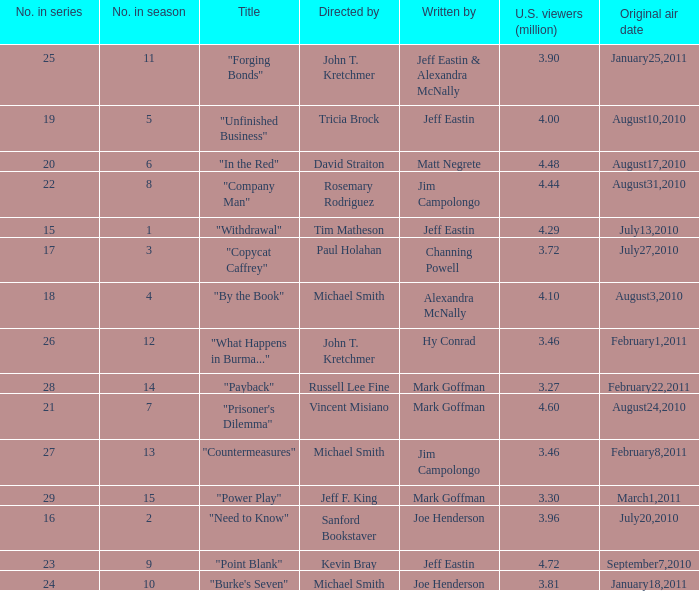How many millions of people in the US watched when Kevin Bray was director? 4.72. Write the full table. {'header': ['No. in series', 'No. in season', 'Title', 'Directed by', 'Written by', 'U.S. viewers (million)', 'Original air date'], 'rows': [['25', '11', '"Forging Bonds"', 'John T. Kretchmer', 'Jeff Eastin & Alexandra McNally', '3.90', 'January25,2011'], ['19', '5', '"Unfinished Business"', 'Tricia Brock', 'Jeff Eastin', '4.00', 'August10,2010'], ['20', '6', '"In the Red"', 'David Straiton', 'Matt Negrete', '4.48', 'August17,2010'], ['22', '8', '"Company Man"', 'Rosemary Rodriguez', 'Jim Campolongo', '4.44', 'August31,2010'], ['15', '1', '"Withdrawal"', 'Tim Matheson', 'Jeff Eastin', '4.29', 'July13,2010'], ['17', '3', '"Copycat Caffrey"', 'Paul Holahan', 'Channing Powell', '3.72', 'July27,2010'], ['18', '4', '"By the Book"', 'Michael Smith', 'Alexandra McNally', '4.10', 'August3,2010'], ['26', '12', '"What Happens in Burma..."', 'John T. Kretchmer', 'Hy Conrad', '3.46', 'February1,2011'], ['28', '14', '"Payback"', 'Russell Lee Fine', 'Mark Goffman', '3.27', 'February22,2011'], ['21', '7', '"Prisoner\'s Dilemma"', 'Vincent Misiano', 'Mark Goffman', '4.60', 'August24,2010'], ['27', '13', '"Countermeasures"', 'Michael Smith', 'Jim Campolongo', '3.46', 'February8,2011'], ['29', '15', '"Power Play"', 'Jeff F. King', 'Mark Goffman', '3.30', 'March1,2011'], ['16', '2', '"Need to Know"', 'Sanford Bookstaver', 'Joe Henderson', '3.96', 'July20,2010'], ['23', '9', '"Point Blank"', 'Kevin Bray', 'Jeff Eastin', '4.72', 'September7,2010'], ['24', '10', '"Burke\'s Seven"', 'Michael Smith', 'Joe Henderson', '3.81', 'January18,2011']]} 